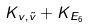<formula> <loc_0><loc_0><loc_500><loc_500>K _ { v , \tilde { v } } + K _ { E _ { 6 } }</formula> 